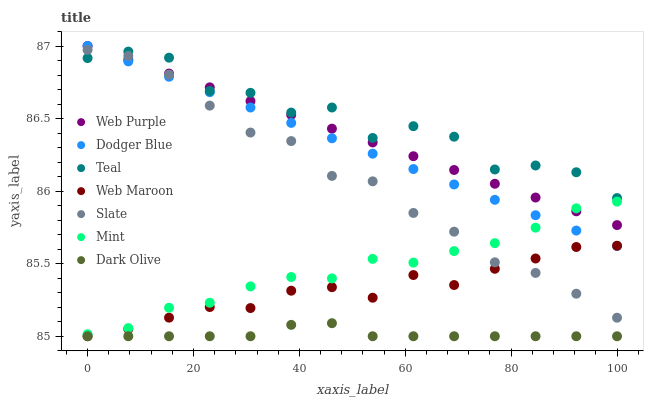Does Dark Olive have the minimum area under the curve?
Answer yes or no. Yes. Does Teal have the maximum area under the curve?
Answer yes or no. Yes. Does Web Maroon have the minimum area under the curve?
Answer yes or no. No. Does Web Maroon have the maximum area under the curve?
Answer yes or no. No. Is Web Purple the smoothest?
Answer yes or no. Yes. Is Teal the roughest?
Answer yes or no. Yes. Is Dark Olive the smoothest?
Answer yes or no. No. Is Dark Olive the roughest?
Answer yes or no. No. Does Dark Olive have the lowest value?
Answer yes or no. Yes. Does Web Purple have the lowest value?
Answer yes or no. No. Does Dodger Blue have the highest value?
Answer yes or no. Yes. Does Web Maroon have the highest value?
Answer yes or no. No. Is Dark Olive less than Web Purple?
Answer yes or no. Yes. Is Teal greater than Dark Olive?
Answer yes or no. Yes. Does Dodger Blue intersect Mint?
Answer yes or no. Yes. Is Dodger Blue less than Mint?
Answer yes or no. No. Is Dodger Blue greater than Mint?
Answer yes or no. No. Does Dark Olive intersect Web Purple?
Answer yes or no. No. 